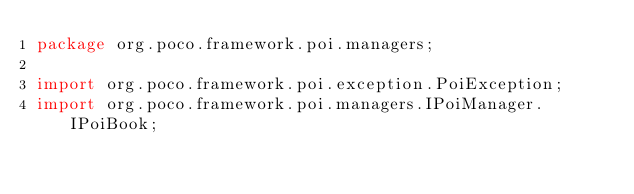<code> <loc_0><loc_0><loc_500><loc_500><_Java_>package org.poco.framework.poi.managers;

import org.poco.framework.poi.exception.PoiException;
import org.poco.framework.poi.managers.IPoiManager.IPoiBook;</code> 